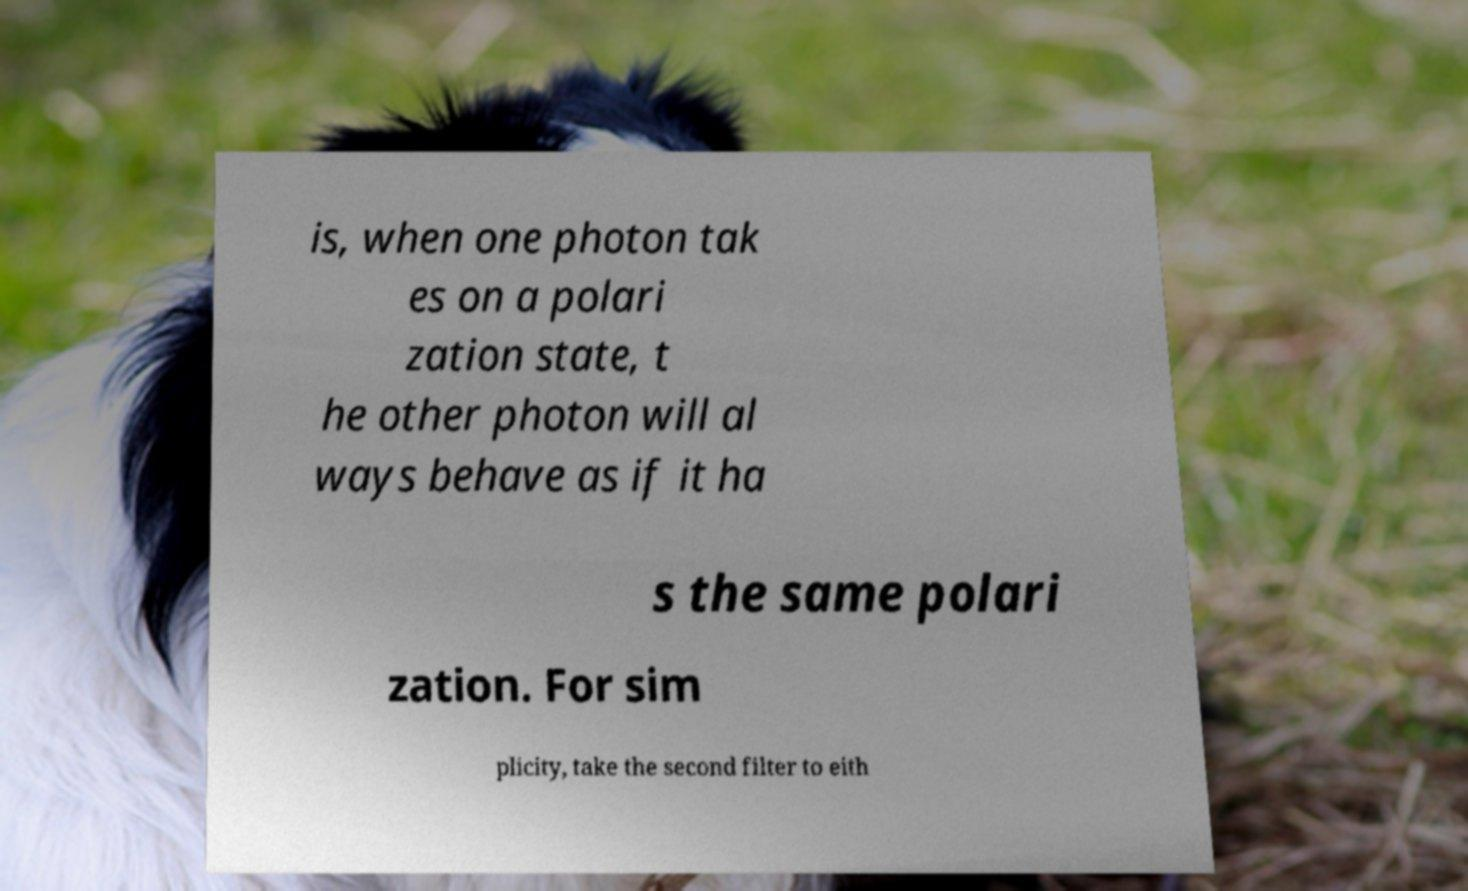Please identify and transcribe the text found in this image. is, when one photon tak es on a polari zation state, t he other photon will al ways behave as if it ha s the same polari zation. For sim plicity, take the second filter to eith 